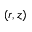Convert formula to latex. <formula><loc_0><loc_0><loc_500><loc_500>( r , z )</formula> 